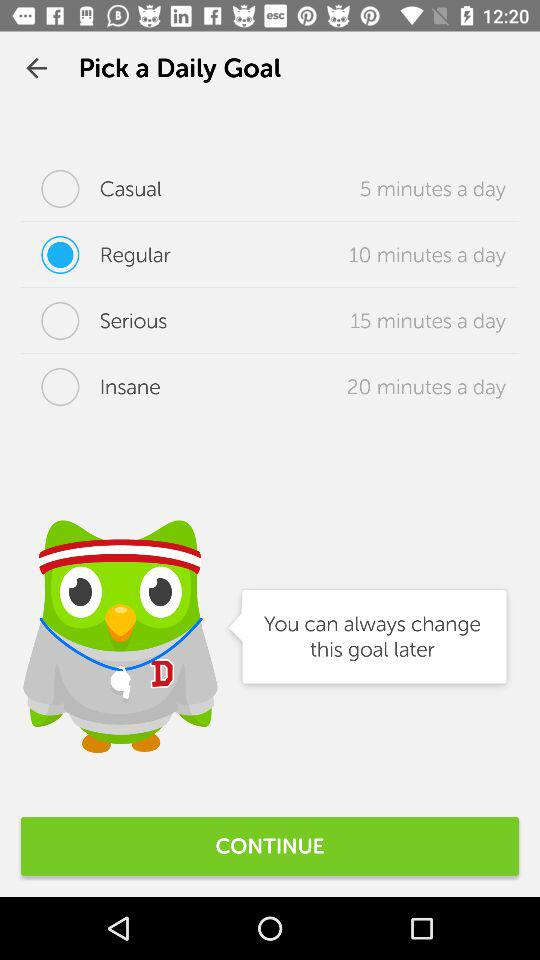What's the selected daily goal option? The selected daily goal option is "Regular". 